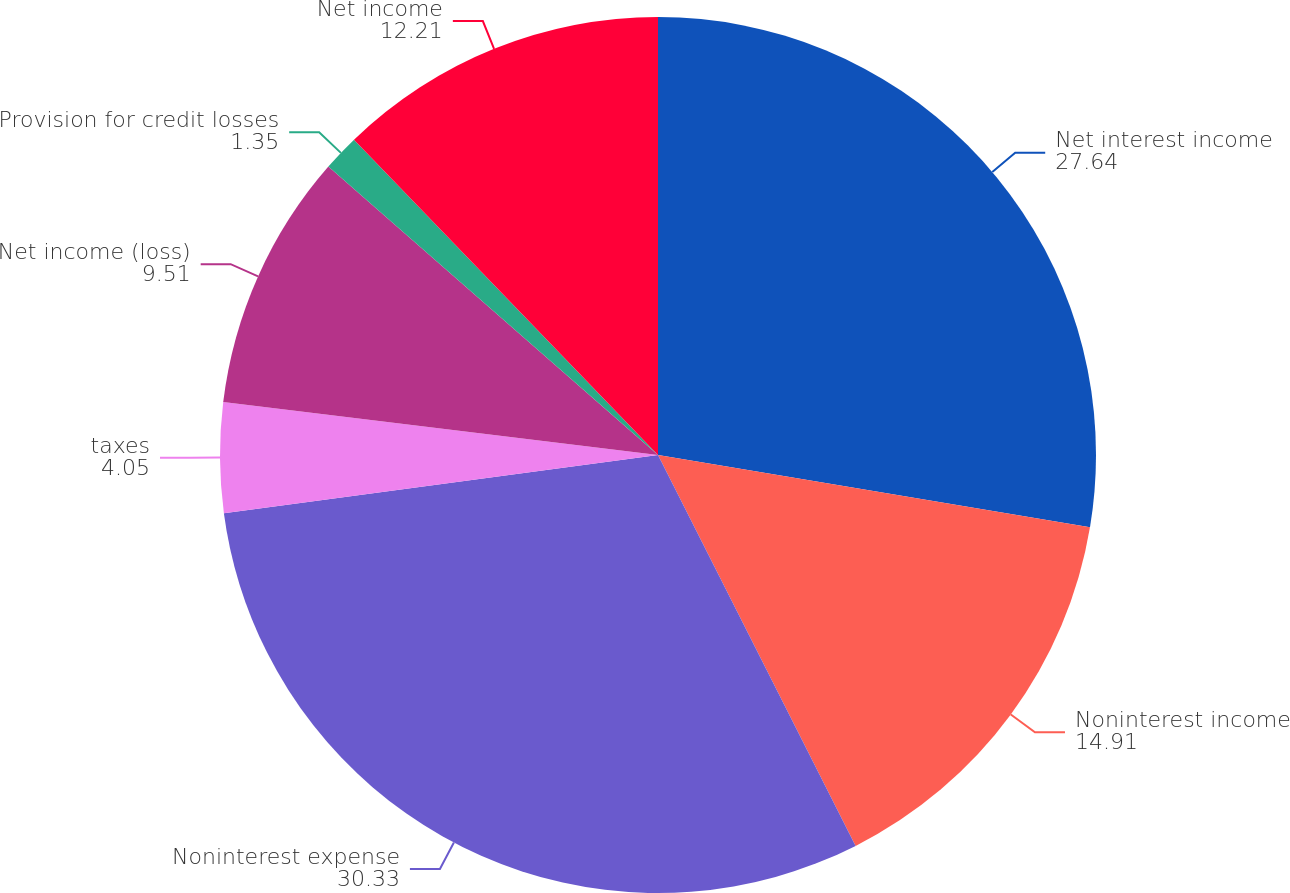<chart> <loc_0><loc_0><loc_500><loc_500><pie_chart><fcel>Net interest income<fcel>Noninterest income<fcel>Noninterest expense<fcel>taxes<fcel>Net income (loss)<fcel>Provision for credit losses<fcel>Net income<nl><fcel>27.64%<fcel>14.91%<fcel>30.33%<fcel>4.05%<fcel>9.51%<fcel>1.35%<fcel>12.21%<nl></chart> 